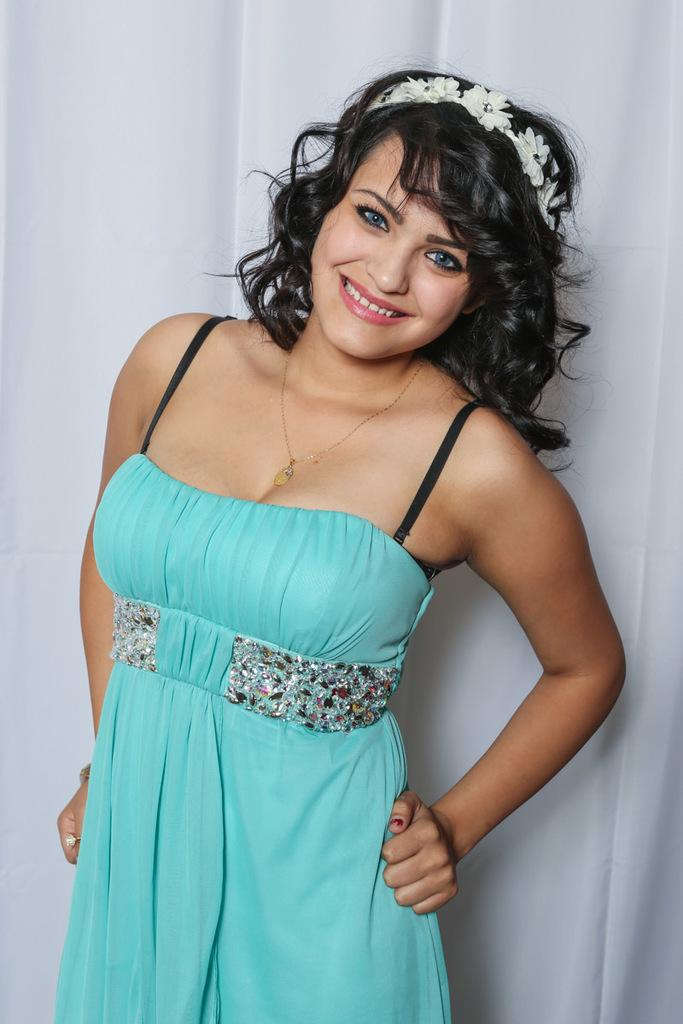Who is present in the image? There is a woman in the image. What is the woman wearing? The woman is wearing a blue and black colored dress and a white colored headband. What is the woman doing in the image? The woman is standing and smiling. What is the color of the background in the image? The background of the image is white. Where can the woman be seen shopping for dresses in the image? There is no indication of shopping or dresses in the image; it only shows a woman standing and smiling. 